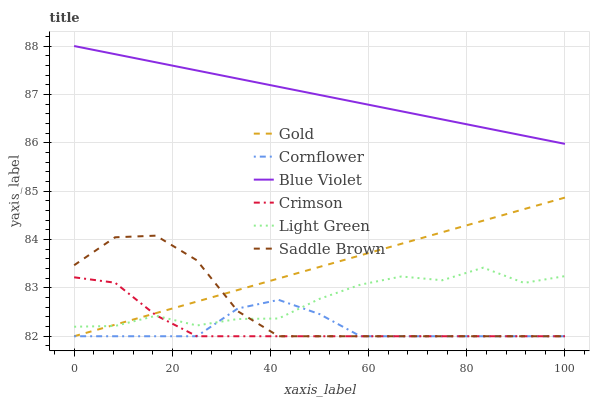Does Cornflower have the minimum area under the curve?
Answer yes or no. Yes. Does Blue Violet have the maximum area under the curve?
Answer yes or no. Yes. Does Gold have the minimum area under the curve?
Answer yes or no. No. Does Gold have the maximum area under the curve?
Answer yes or no. No. Is Gold the smoothest?
Answer yes or no. Yes. Is Light Green the roughest?
Answer yes or no. Yes. Is Light Green the smoothest?
Answer yes or no. No. Is Gold the roughest?
Answer yes or no. No. Does Light Green have the lowest value?
Answer yes or no. No. Does Gold have the highest value?
Answer yes or no. No. Is Cornflower less than Blue Violet?
Answer yes or no. Yes. Is Blue Violet greater than Gold?
Answer yes or no. Yes. Does Cornflower intersect Blue Violet?
Answer yes or no. No. 